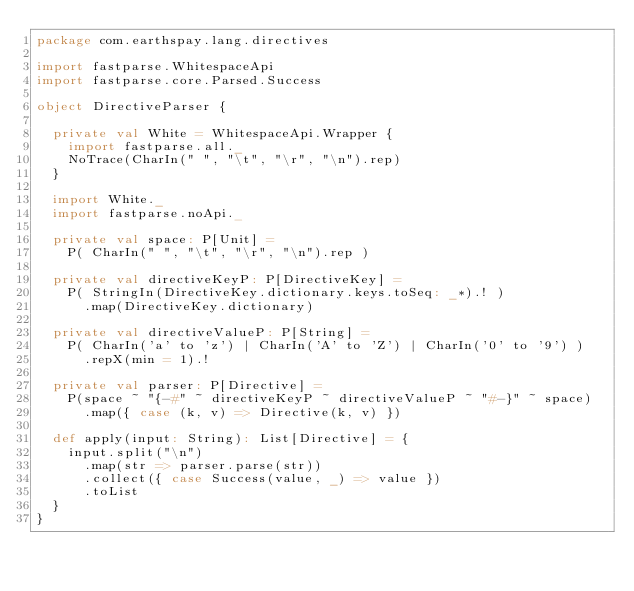Convert code to text. <code><loc_0><loc_0><loc_500><loc_500><_Scala_>package com.earthspay.lang.directives

import fastparse.WhitespaceApi
import fastparse.core.Parsed.Success

object DirectiveParser {

  private val White = WhitespaceApi.Wrapper {
    import fastparse.all._
    NoTrace(CharIn(" ", "\t", "\r", "\n").rep)
  }

  import White._
  import fastparse.noApi._

  private val space: P[Unit] =
    P( CharIn(" ", "\t", "\r", "\n").rep )

  private val directiveKeyP: P[DirectiveKey] =
    P( StringIn(DirectiveKey.dictionary.keys.toSeq: _*).! )
      .map(DirectiveKey.dictionary)

  private val directiveValueP: P[String] =
    P( CharIn('a' to 'z') | CharIn('A' to 'Z') | CharIn('0' to '9') )
      .repX(min = 1).!

  private val parser: P[Directive] =
    P(space ~ "{-#" ~ directiveKeyP ~ directiveValueP ~ "#-}" ~ space)
      .map({ case (k, v) => Directive(k, v) })

  def apply(input: String): List[Directive] = {
    input.split("\n")
      .map(str => parser.parse(str))
      .collect({ case Success(value, _) => value })
      .toList
  }
}
</code> 